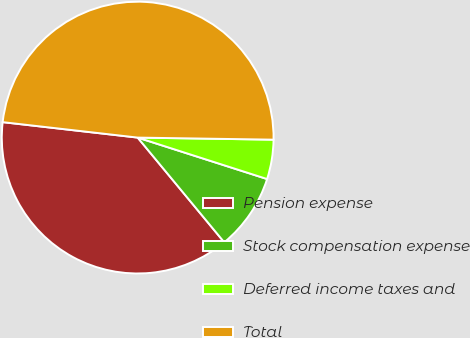<chart> <loc_0><loc_0><loc_500><loc_500><pie_chart><fcel>Pension expense<fcel>Stock compensation expense<fcel>Deferred income taxes and<fcel>Total<nl><fcel>37.81%<fcel>9.07%<fcel>4.69%<fcel>48.43%<nl></chart> 